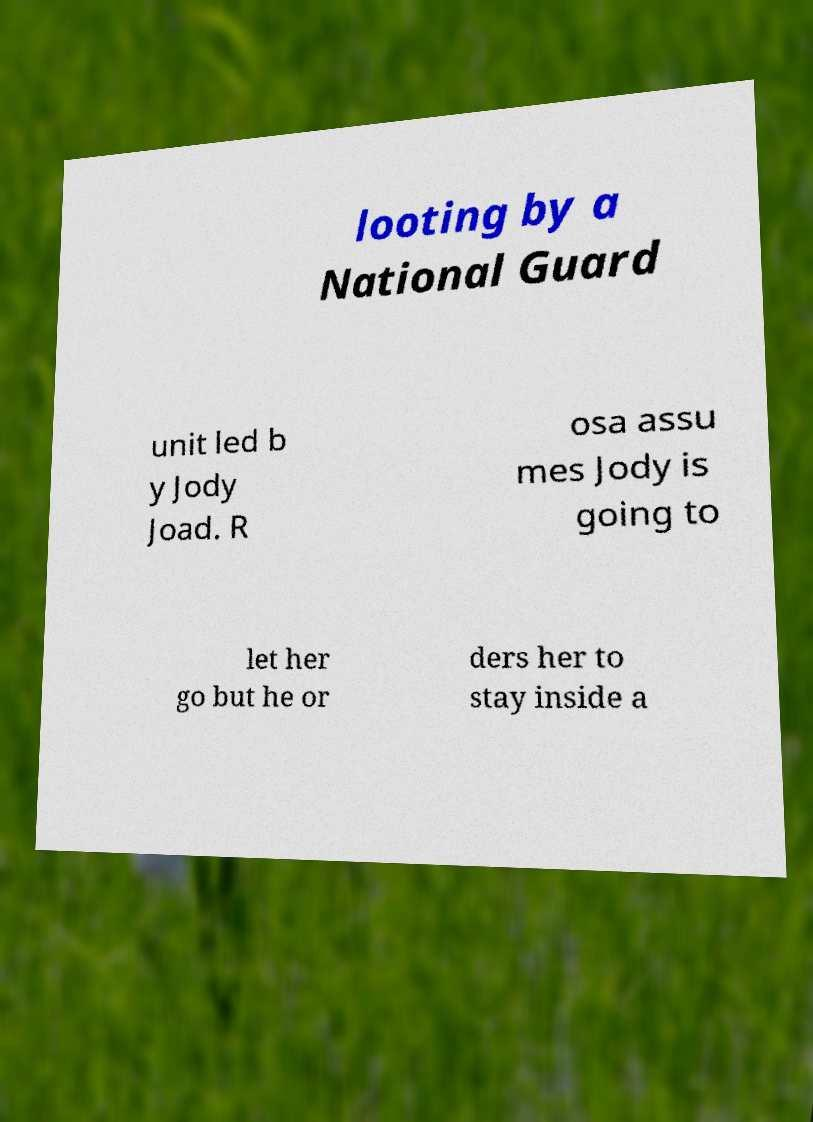What messages or text are displayed in this image? I need them in a readable, typed format. looting by a National Guard unit led b y Jody Joad. R osa assu mes Jody is going to let her go but he or ders her to stay inside a 